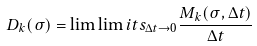Convert formula to latex. <formula><loc_0><loc_0><loc_500><loc_500>D _ { k } ( \sigma ) = \lim \lim i t s _ { \Delta t \to 0 } \frac { M _ { k } ( \sigma , \Delta t ) } { \Delta t }</formula> 